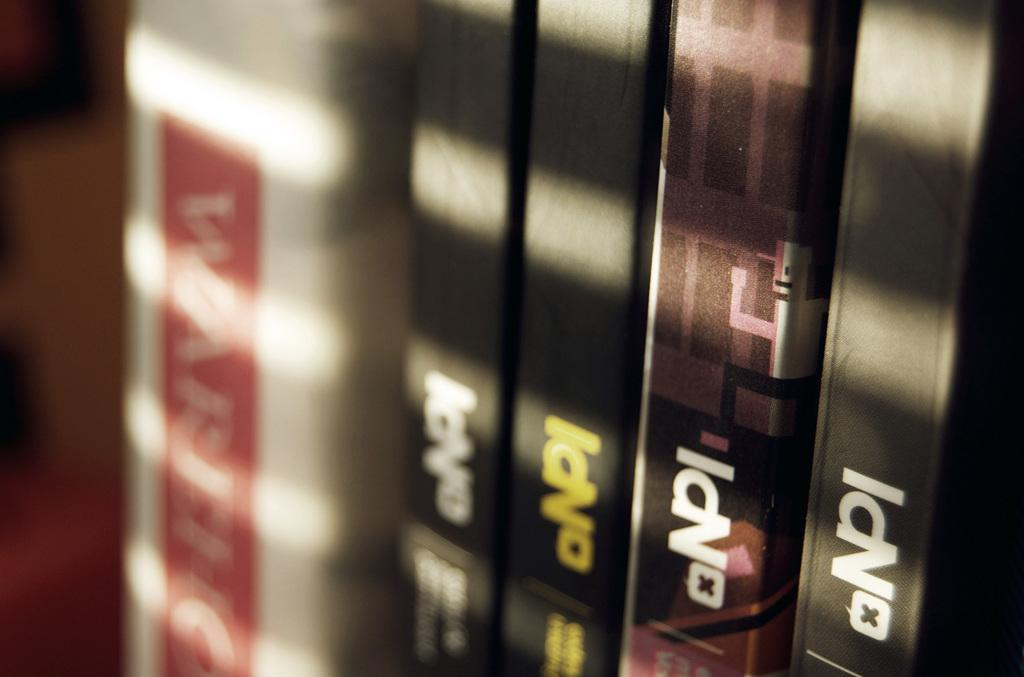<image>
Summarize the visual content of the image. a series of books that has NPI on them 